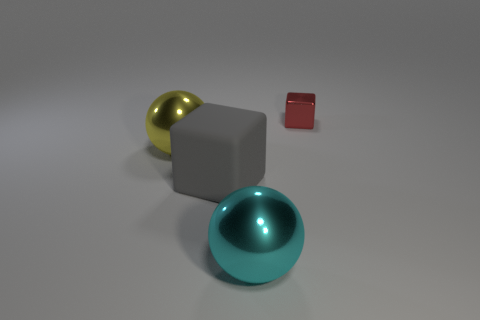Subtract all yellow spheres. How many spheres are left? 1 Subtract 2 balls. How many balls are left? 0 Subtract all blue spheres. Subtract all purple blocks. How many spheres are left? 2 Subtract all yellow cylinders. How many red balls are left? 0 Subtract all large cyan metallic cubes. Subtract all cyan metallic objects. How many objects are left? 3 Add 4 rubber blocks. How many rubber blocks are left? 5 Add 1 green rubber cylinders. How many green rubber cylinders exist? 1 Add 1 big yellow metallic balls. How many objects exist? 5 Subtract 1 cyan spheres. How many objects are left? 3 